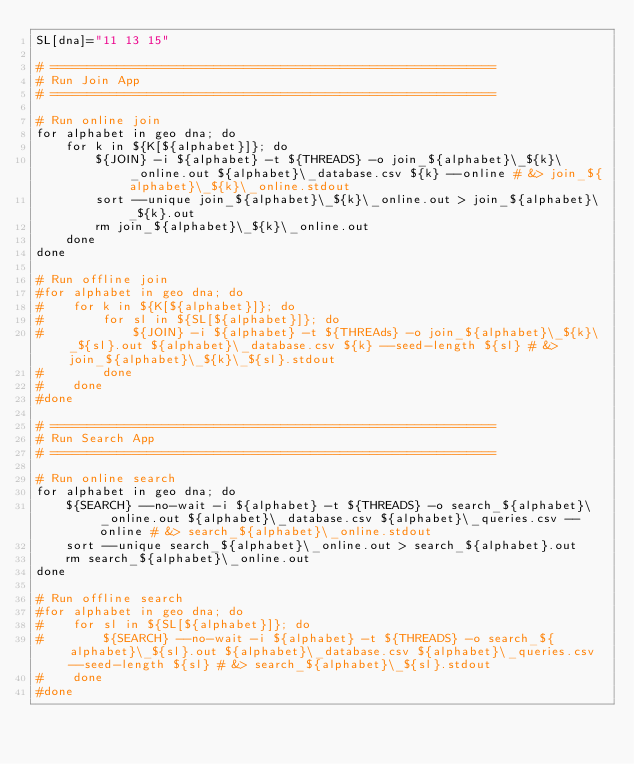<code> <loc_0><loc_0><loc_500><loc_500><_Bash_>SL[dna]="11 13 15"

# ============================================================
# Run Join App
# ============================================================

# Run online join
for alphabet in geo dna; do
    for k in ${K[${alphabet}]}; do
        ${JOIN} -i ${alphabet} -t ${THREADS} -o join_${alphabet}\_${k}\_online.out ${alphabet}\_database.csv ${k} --online # &> join_${alphabet}\_${k}\_online.stdout
        sort --unique join_${alphabet}\_${k}\_online.out > join_${alphabet}\_${k}.out
        rm join_${alphabet}\_${k}\_online.out
    done
done

# Run offline join
#for alphabet in geo dna; do
#    for k in ${K[${alphabet}]}; do
#        for sl in ${SL[${alphabet}]}; do
#            ${JOIN} -i ${alphabet} -t ${THREAds} -o join_${alphabet}\_${k}\_${sl}.out ${alphabet}\_database.csv ${k} --seed-length ${sl} # &> join_${alphabet}\_${k}\_${sl}.stdout
#        done
#    done
#done

# ============================================================
# Run Search App
# ============================================================

# Run online search
for alphabet in geo dna; do
    ${SEARCH} --no-wait -i ${alphabet} -t ${THREADS} -o search_${alphabet}\_online.out ${alphabet}\_database.csv ${alphabet}\_queries.csv --online # &> search_${alphabet}\_online.stdout
    sort --unique search_${alphabet}\_online.out > search_${alphabet}.out
    rm search_${alphabet}\_online.out
done

# Run offline search
#for alphabet in geo dna; do
#    for sl in ${SL[${alphabet}]}; do
#        ${SEARCH} --no-wait -i ${alphabet} -t ${THREADS} -o search_${alphabet}\_${sl}.out ${alphabet}\_database.csv ${alphabet}\_queries.csv --seed-length ${sl} # &> search_${alphabet}\_${sl}.stdout
#    done
#done</code> 